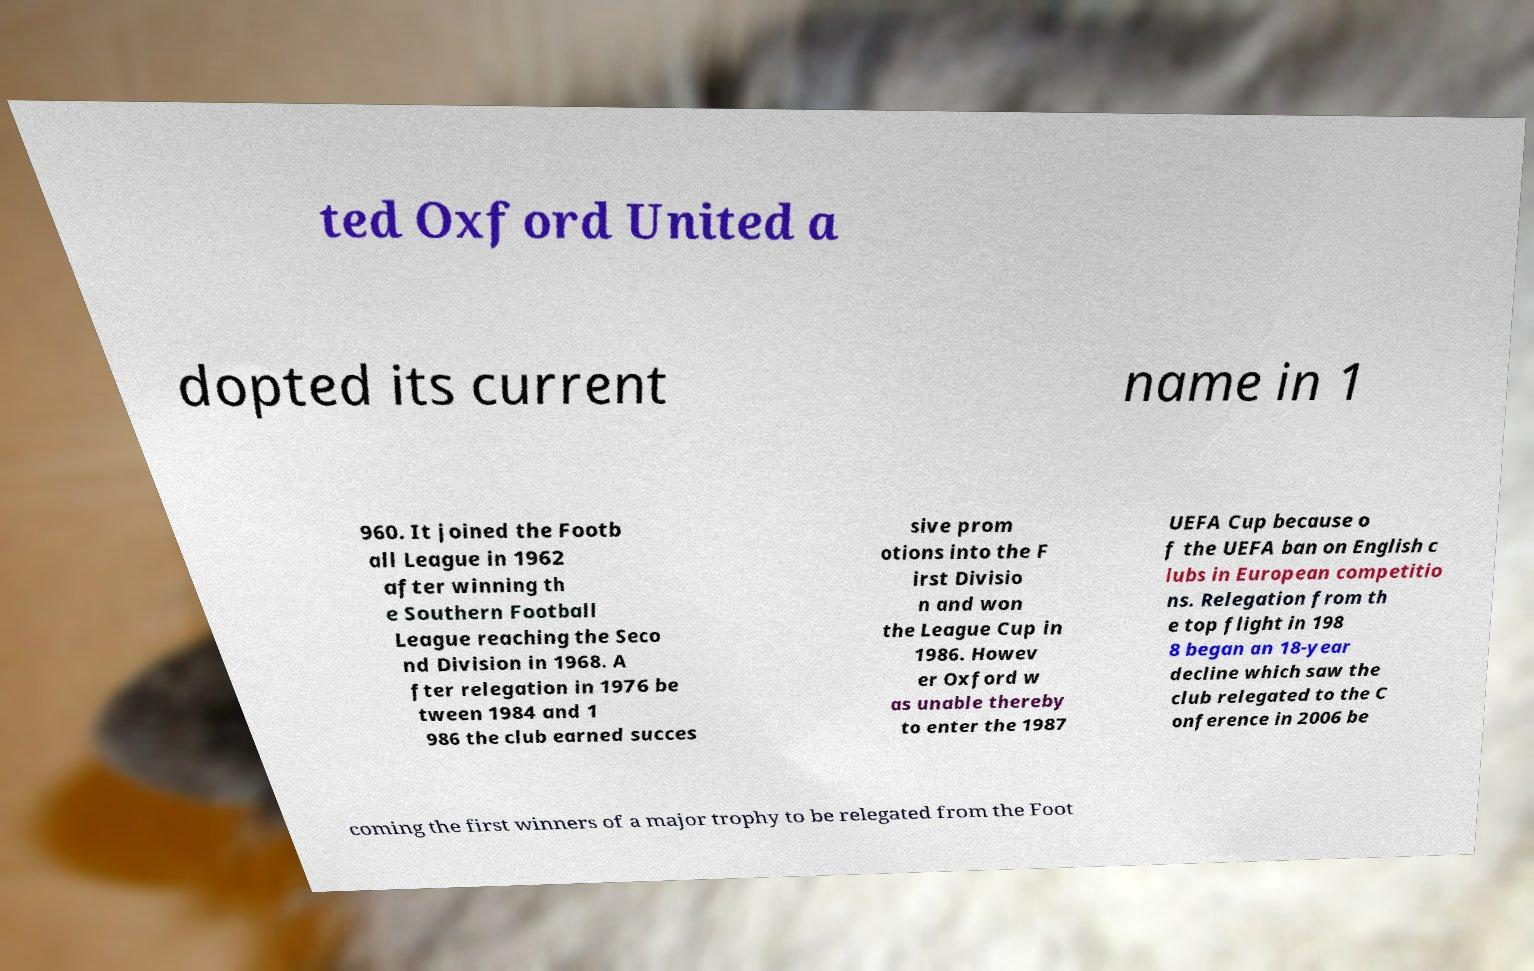Could you assist in decoding the text presented in this image and type it out clearly? ted Oxford United a dopted its current name in 1 960. It joined the Footb all League in 1962 after winning th e Southern Football League reaching the Seco nd Division in 1968. A fter relegation in 1976 be tween 1984 and 1 986 the club earned succes sive prom otions into the F irst Divisio n and won the League Cup in 1986. Howev er Oxford w as unable thereby to enter the 1987 UEFA Cup because o f the UEFA ban on English c lubs in European competitio ns. Relegation from th e top flight in 198 8 began an 18-year decline which saw the club relegated to the C onference in 2006 be coming the first winners of a major trophy to be relegated from the Foot 